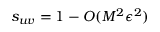Convert formula to latex. <formula><loc_0><loc_0><loc_500><loc_500>s _ { u v } = 1 - O ( M ^ { 2 } \epsilon ^ { 2 } )</formula> 